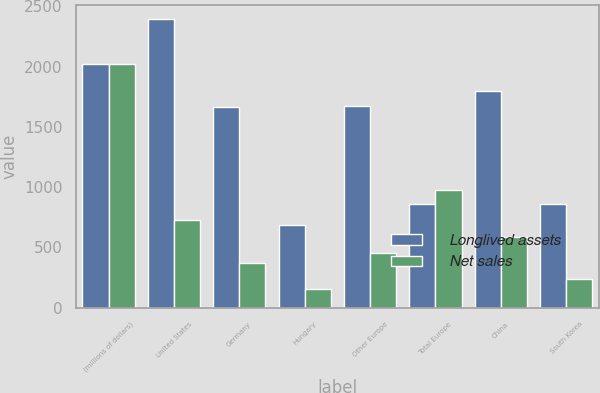Convert chart. <chart><loc_0><loc_0><loc_500><loc_500><stacked_bar_chart><ecel><fcel>(millions of dollars)<fcel>United States<fcel>Germany<fcel>Hungary<fcel>Other Europe<fcel>Total Europe<fcel>China<fcel>South Korea<nl><fcel>Longlived assets<fcel>2018<fcel>2393.5<fcel>1665.1<fcel>687.3<fcel>1669.5<fcel>858.8<fcel>1801.1<fcel>858.8<nl><fcel>Net sales<fcel>2018<fcel>728.9<fcel>371.1<fcel>153<fcel>452.5<fcel>976.6<fcel>589.3<fcel>235.1<nl></chart> 